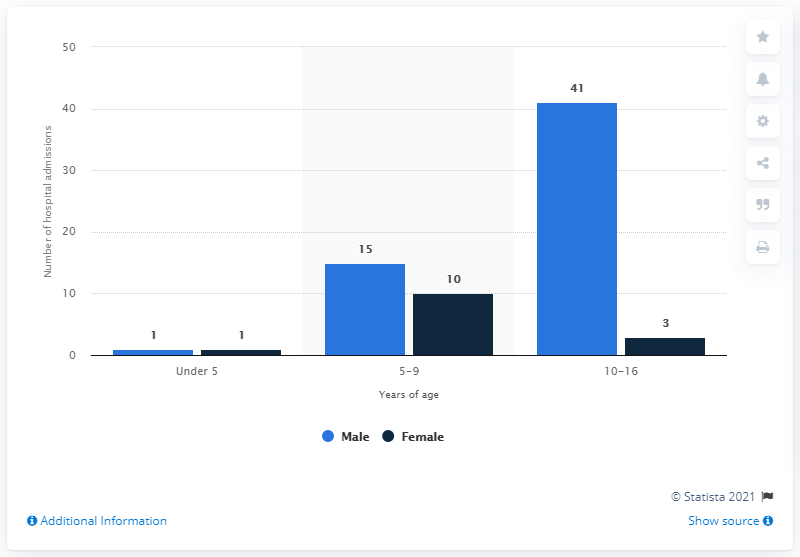Draw attention to some important aspects in this diagram. In the 2019/2020 fiscal year, a total of 41 boys and three girls were admitted to hospitals in Scotland as injured cyclists. 